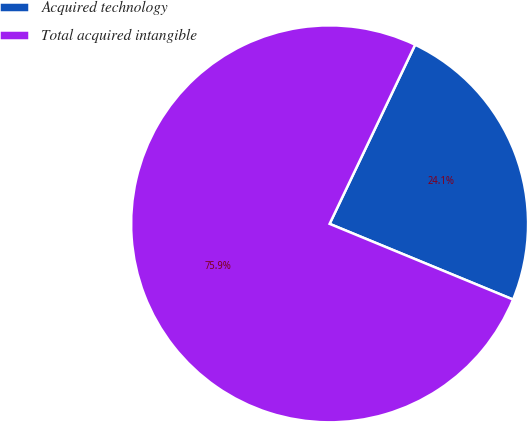Convert chart to OTSL. <chart><loc_0><loc_0><loc_500><loc_500><pie_chart><fcel>Acquired technology<fcel>Total acquired intangible<nl><fcel>24.14%<fcel>75.86%<nl></chart> 